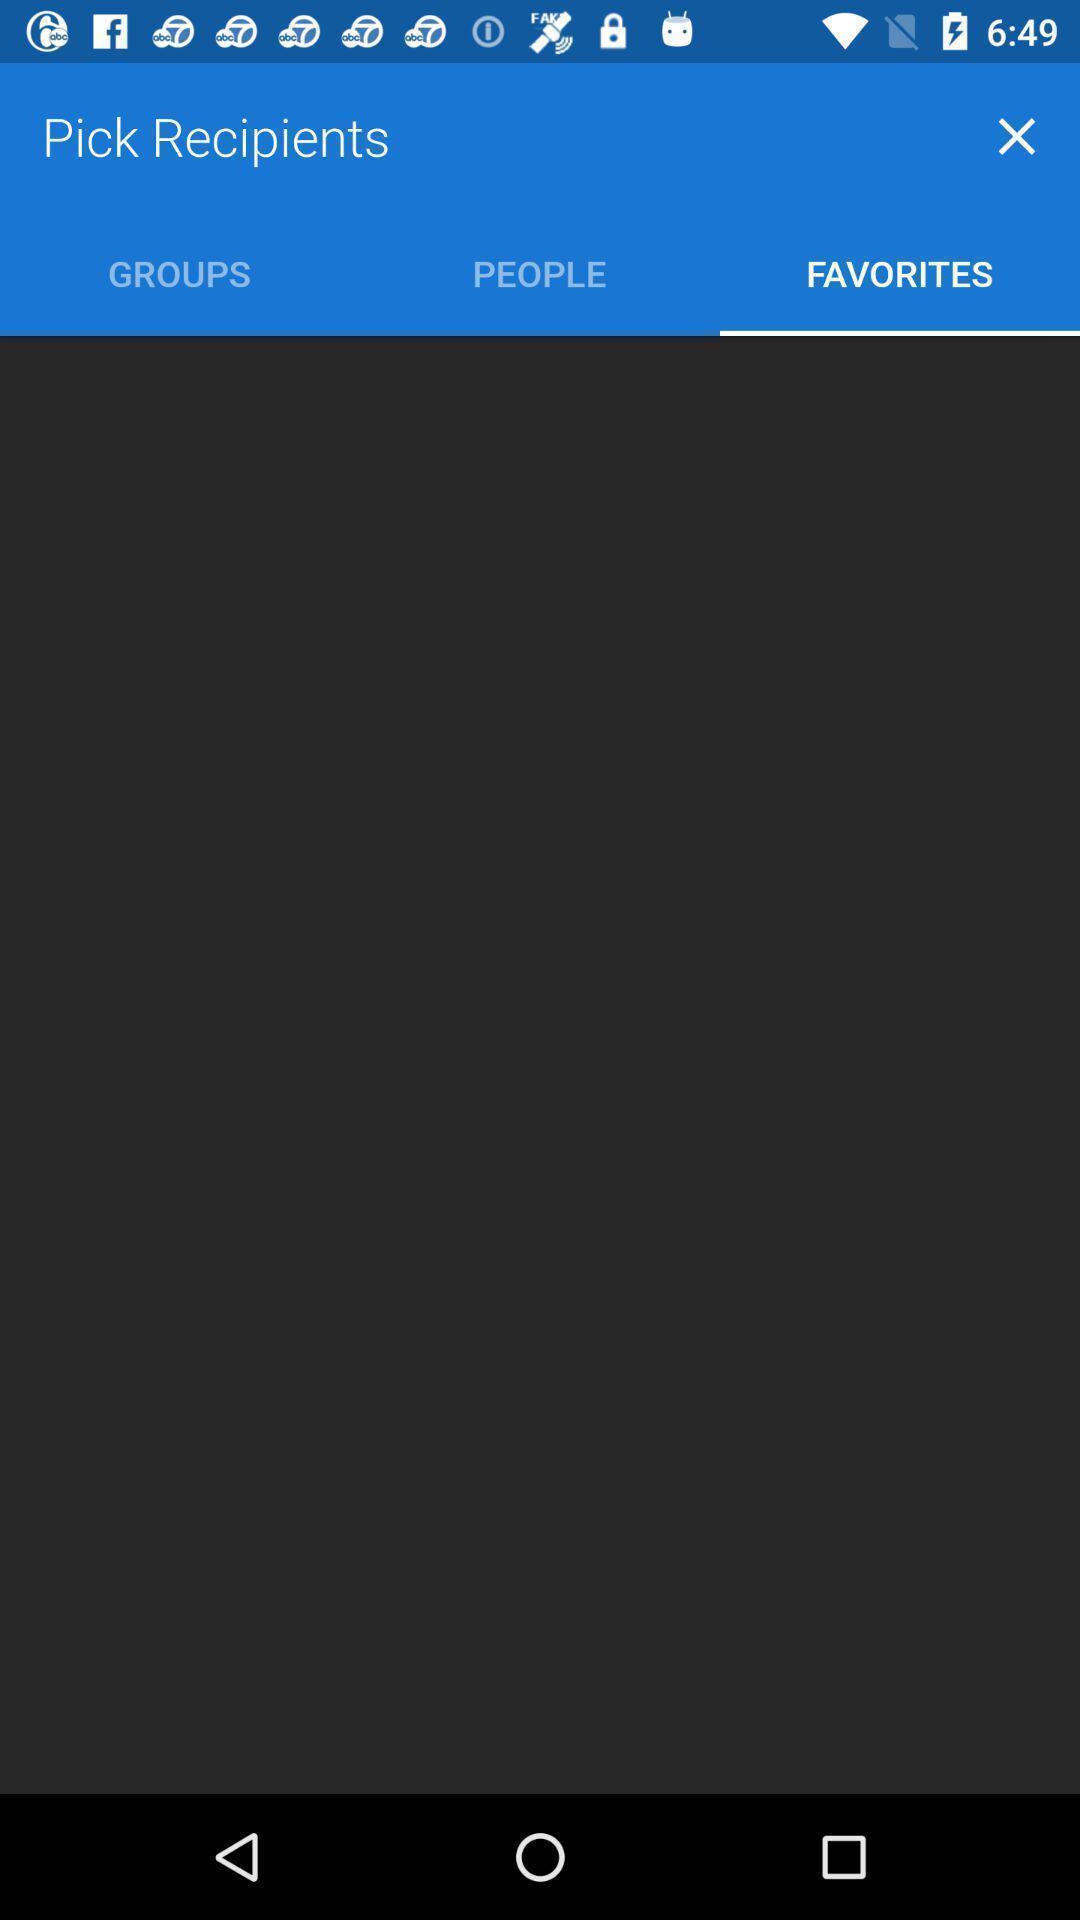Provide a detailed account of this screenshot. Screen displaying favorites page. 